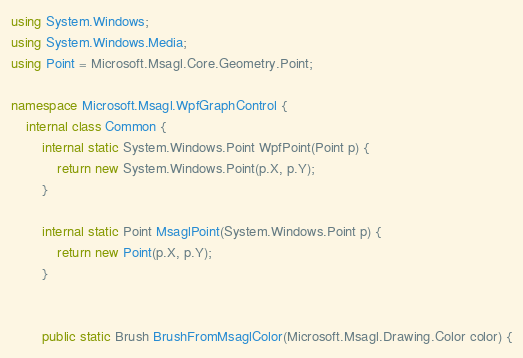Convert code to text. <code><loc_0><loc_0><loc_500><loc_500><_C#_>using System.Windows;
using System.Windows.Media;
using Point = Microsoft.Msagl.Core.Geometry.Point;

namespace Microsoft.Msagl.WpfGraphControl {
    internal class Common {
        internal static System.Windows.Point WpfPoint(Point p) {
            return new System.Windows.Point(p.X, p.Y);
        }

        internal static Point MsaglPoint(System.Windows.Point p) {
            return new Point(p.X, p.Y);
        }


        public static Brush BrushFromMsaglColor(Microsoft.Msagl.Drawing.Color color) {</code> 